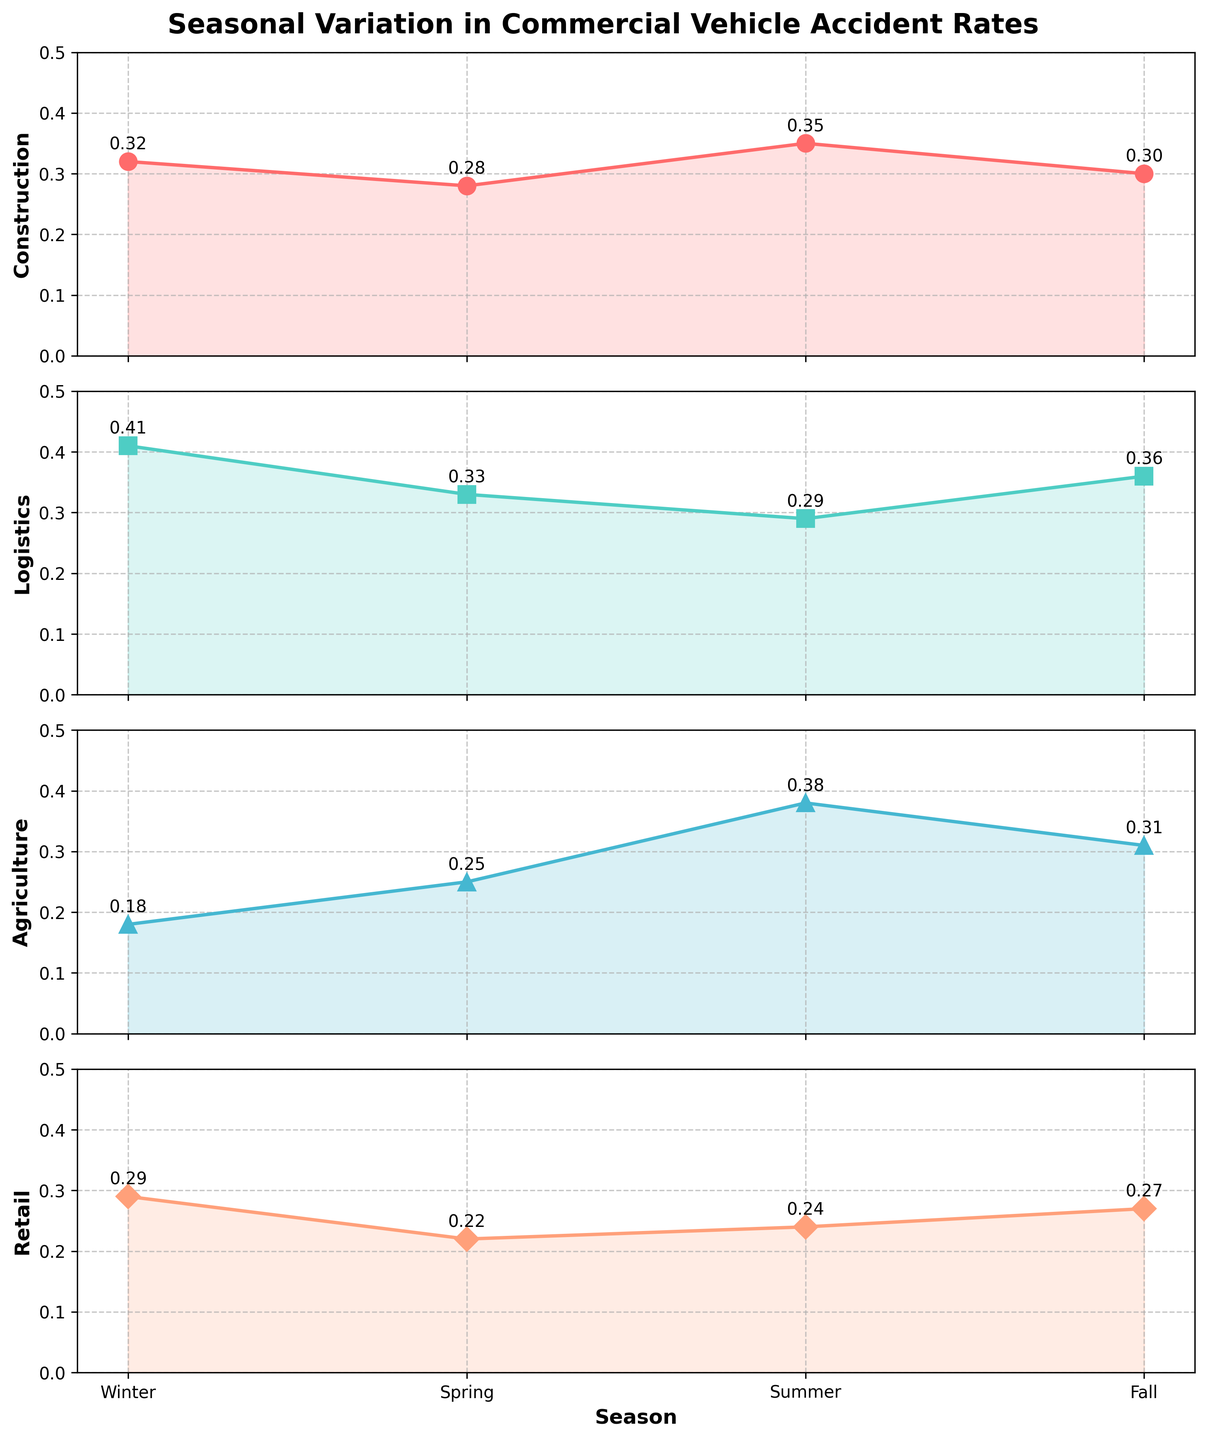What's the title of the figure? The title is usually displayed at the top of the figure and provides an overview of what the figure represents. Here, it is clearly mentioned at the top.
Answer: "Seasonal Variation in Commercial Vehicle Accident Rates" Which industry has the highest accident rate in Summer? Look at the segment for Summer and identify the industry line with the highest value; "Summer" is on the x-axis and the peak for Summer can be observed.
Answer: Agriculture What is the accident rate for the Logistics industry during Winter? Find the Winter label on the x-axis and then locate the corresponding value on the Logistics plot. The value is annotated next to the data point.
Answer: 0.41 How does the accident rate for Construction change from Spring to Fall? Track each value for Construction across the seasons from Spring to Fall. Note the change in values by observing the annotated data points.
Answer: Increases from 0.28 to 0.30 Compare the accident rates between Agriculture and Retail during Fall. Which one is higher? Look at the Fall section and compare the values for Agriculture and Retail, which are annotated next to their respective data points.
Answer: Agriculture What is the overall trend in accident rates for the Construction industry throughout the year? Observe the Construction industry segment across all seasons and describe whether it generally increases, decreases, or remains constant. Analyze the plot line and annotations.
Answer: Slight fluctuation with minor peaks in Summer and Winter Which industry shows the smallest variation in accident rates throughout the seasons? Compare the range of variation (difference between max and min values) for each industry. Identify the one with the lowest range.
Answer: Retail What's the difference in accident rates for Logistics between the highest and lowest seasons? Identify the highest (Winter) and lowest (Summer) accident rates for Logistics and calculate the difference.
Answer: 0.12 (0.41 - 0.29) Which two seasons have the closest accident rates for Agriculture? Find and compare the values for each season for Agriculture, and note the seasons with the closest values.
Answer: Fall and Spring (0.31 and 0.25) In which season does Retail have the second highest accident rate? Observe the accident rate annotations for Retail across all seasons and identify the second highest value and its corresponding season.
Answer: Winter 